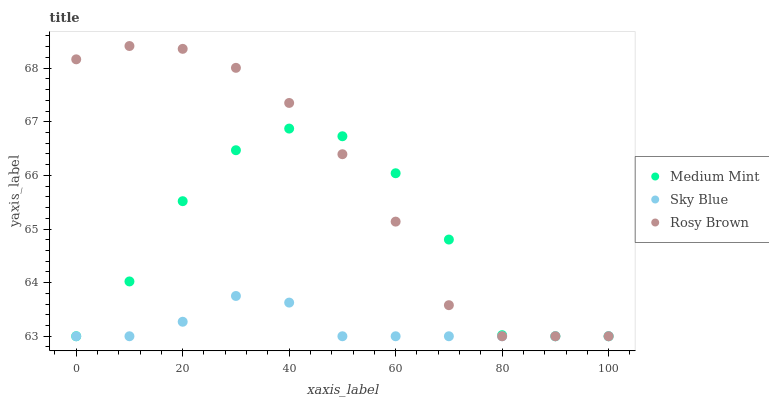Does Sky Blue have the minimum area under the curve?
Answer yes or no. Yes. Does Rosy Brown have the maximum area under the curve?
Answer yes or no. Yes. Does Rosy Brown have the minimum area under the curve?
Answer yes or no. No. Does Sky Blue have the maximum area under the curve?
Answer yes or no. No. Is Sky Blue the smoothest?
Answer yes or no. Yes. Is Medium Mint the roughest?
Answer yes or no. Yes. Is Rosy Brown the smoothest?
Answer yes or no. No. Is Rosy Brown the roughest?
Answer yes or no. No. Does Medium Mint have the lowest value?
Answer yes or no. Yes. Does Rosy Brown have the highest value?
Answer yes or no. Yes. Does Sky Blue have the highest value?
Answer yes or no. No. Does Medium Mint intersect Sky Blue?
Answer yes or no. Yes. Is Medium Mint less than Sky Blue?
Answer yes or no. No. Is Medium Mint greater than Sky Blue?
Answer yes or no. No. 